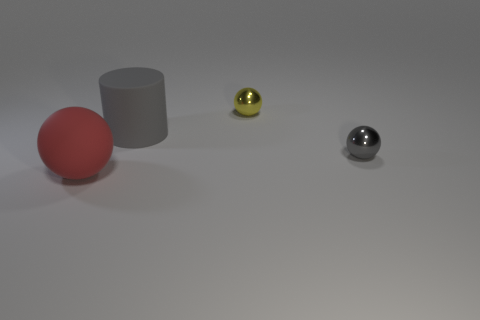What color is the tiny object to the right of the tiny shiny sphere behind the gray shiny object?
Offer a very short reply. Gray. How many other objects are the same shape as the small yellow object?
Your answer should be very brief. 2. Is there a small gray sphere made of the same material as the yellow object?
Your answer should be very brief. Yes. There is a ball that is the same size as the rubber cylinder; what is it made of?
Offer a terse response. Rubber. There is a small ball in front of the metal object behind the rubber object that is behind the big red object; what color is it?
Give a very brief answer. Gray. There is a yellow metal thing behind the large red matte object; is it the same shape as the thing on the right side of the yellow object?
Provide a succinct answer. Yes. What number of big gray cylinders are there?
Your answer should be very brief. 1. There is a matte ball that is the same size as the cylinder; what color is it?
Your response must be concise. Red. Is the large thing that is right of the large sphere made of the same material as the large thing that is in front of the small gray thing?
Your response must be concise. Yes. There is a metallic sphere on the left side of the gray thing to the right of the tiny yellow metal ball; what size is it?
Make the answer very short. Small. 